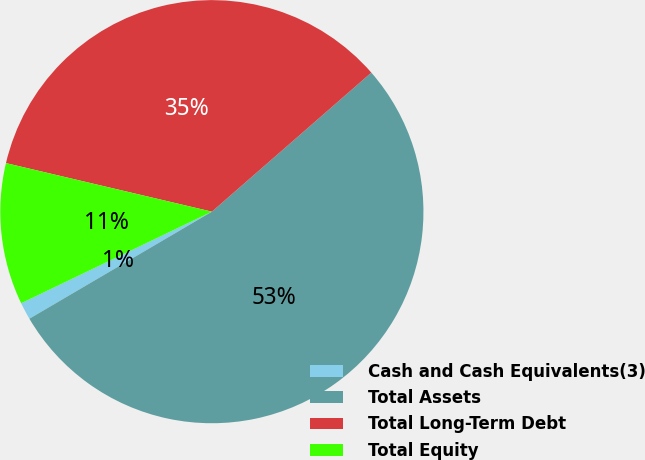<chart> <loc_0><loc_0><loc_500><loc_500><pie_chart><fcel>Cash and Cash Equivalents(3)<fcel>Total Assets<fcel>Total Long-Term Debt<fcel>Total Equity<nl><fcel>1.32%<fcel>52.97%<fcel>34.9%<fcel>10.81%<nl></chart> 